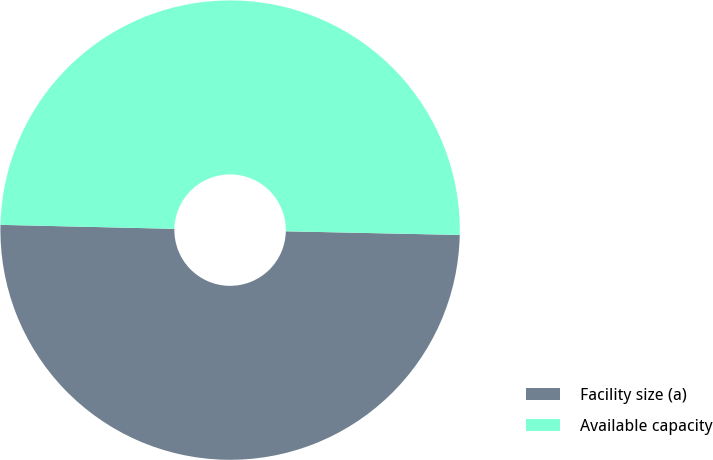<chart> <loc_0><loc_0><loc_500><loc_500><pie_chart><fcel>Facility size (a)<fcel>Available capacity<nl><fcel>50.03%<fcel>49.97%<nl></chart> 